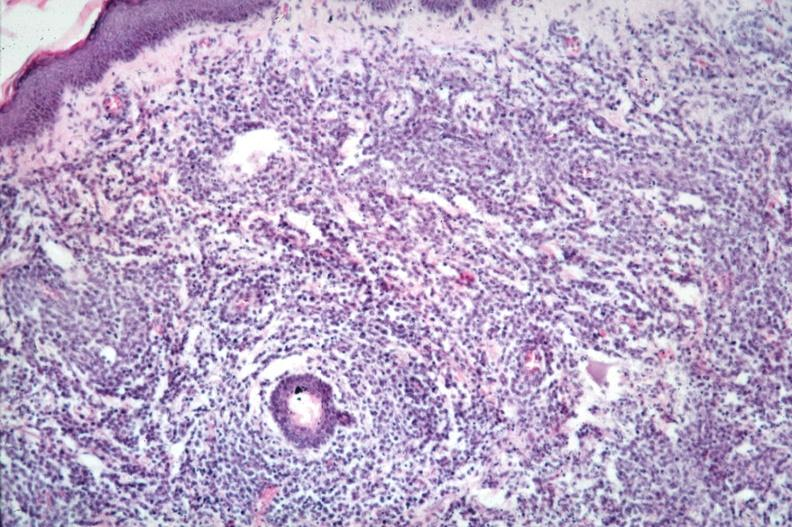what does this image show?
Answer the question using a single word or phrase. Dermal lymphoma infiltrate 